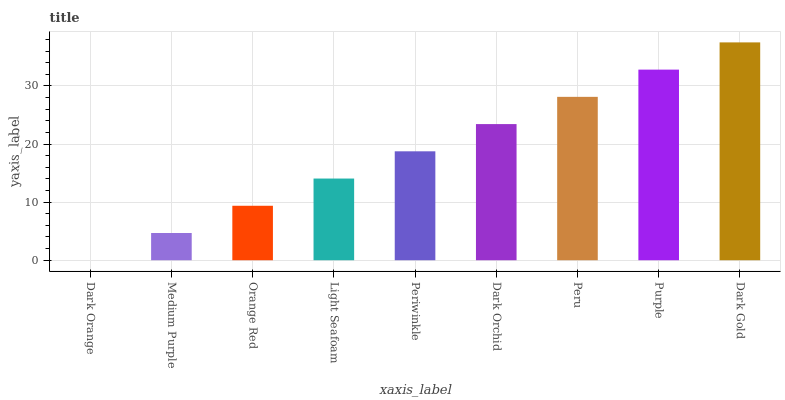Is Medium Purple the minimum?
Answer yes or no. No. Is Medium Purple the maximum?
Answer yes or no. No. Is Medium Purple greater than Dark Orange?
Answer yes or no. Yes. Is Dark Orange less than Medium Purple?
Answer yes or no. Yes. Is Dark Orange greater than Medium Purple?
Answer yes or no. No. Is Medium Purple less than Dark Orange?
Answer yes or no. No. Is Periwinkle the high median?
Answer yes or no. Yes. Is Periwinkle the low median?
Answer yes or no. Yes. Is Dark Gold the high median?
Answer yes or no. No. Is Orange Red the low median?
Answer yes or no. No. 